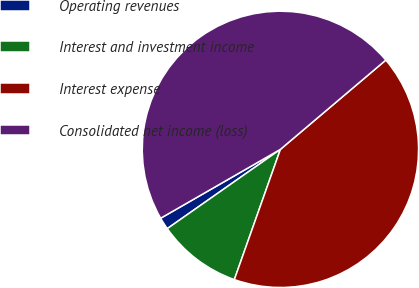Convert chart to OTSL. <chart><loc_0><loc_0><loc_500><loc_500><pie_chart><fcel>Operating revenues<fcel>Interest and investment income<fcel>Interest expense<fcel>Consolidated net income (loss)<nl><fcel>1.42%<fcel>9.86%<fcel>41.59%<fcel>47.12%<nl></chart> 